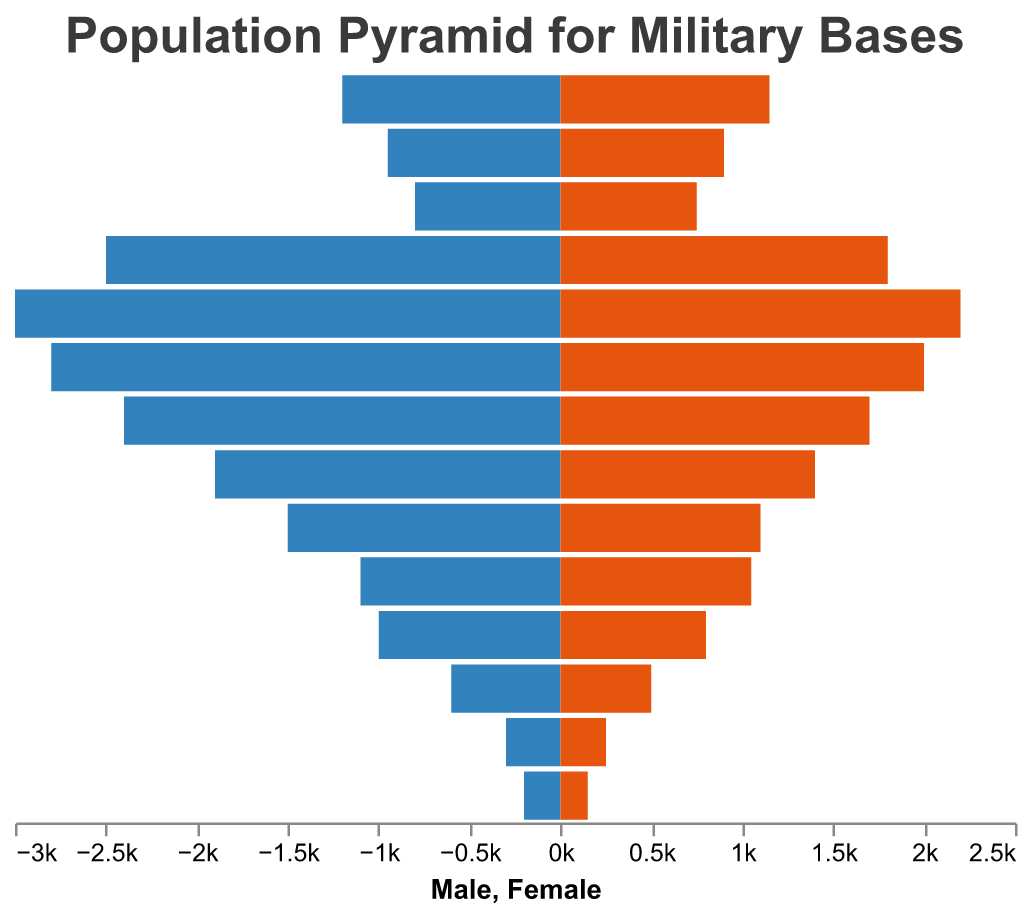What is the title of the figure? The title can be found at the top of the figure. It reads "Population Pyramid for Military Bases."
Answer: Population Pyramid for Military Bases Which age group has the highest male population? By looking at the longest bar on the male side (colored in blue), the age group with the highest male population is 25-29.
Answer: 25-29 What is the male population for the age group 10-14? The male population for each age group is displayed by the length of the bars on the left side of the pyramid. For the age group 10-14, the male population is 950.
Answer: 950 Compare the male and female populations for the age group 20-24. The length of the bars on both sides for the age group 20-24 indicates that the male population is 2500, while the female population is 1800.
Answer: Male: 2500, Female: 1800 Which age group has the smallest total population (male and female combined)? To find the smallest total population for an age group, add the male and female populations for each group and compare. The 65+ age group has the smallest total population with 200 males and 150 females, totaling 350.
Answer: 65+ How many more males are there in the 30-34 age group compared to females? Subtract the female population from the male population in the 30-34 age group. Male population is 2800 and female population is 2000. So, 2800 - 2000 = 800 more males.
Answer: 800 Identify the age group with a male population of 600. Look at the bars on the male side and find the age group corresponding to the bar with a height representing a population of 600. It is the 55-59 age group.
Answer: 55-59 Which gender has a larger population for the age group 45-49, and by how much? Compare the lengths of the bars for the age group 45-49. The male population is 1500 while the female population is 1100. Males have a larger population by 1500 - 1100 = 400.
Answer: Male by 400 What is the total population for the age group 0-4? Add the male and female populations for the age group 0-4. Male: 1200, Female: 1150. So, 1200 + 1150 = 2350.
Answer: 2350 Which age group has a greater difference between male and female populations: 15-19 or 35-39? Calculate and compare the differences: Age group 15-19: 800 males - 750 females = 50. Age group 35-39: 2400 males - 1700 females = 700.
Answer: 35-39 